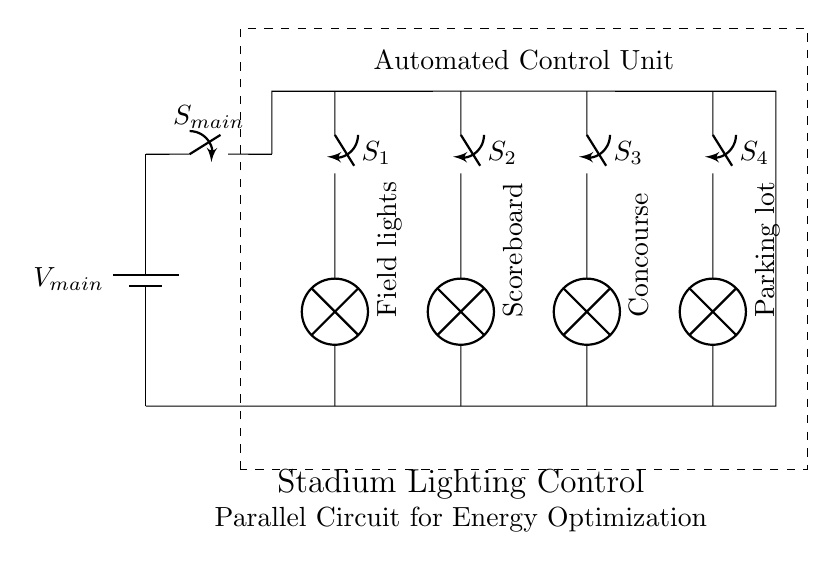What is the main power source in this circuit? The power source is labeled as V_main, indicated at the top left of the circuit diagram.
Answer: V_main How many branches are there in the circuit? There are four branches, each connected to a switch and a lamp, shown as parallel connections.
Answer: Four What does the control unit do? The control unit manages the operation of the entire lighting system by controlling the switches for each branch.
Answer: Automated control What is the purpose of switch S_3? Switch S_3 controls the power to the concourse lights, allowing them to be turned on or off independently from the other lights.
Answer: Concourse lights If all switches are closed, how does current flow? Current flows through each branch independently, allowing multiple lights to operate simultaneously without affecting each other.
Answer: Parallel What happens if switch S_4 is opened? If switch S_4 is opened, the parking lot lights will turn off, but the other branches will remain illuminated.
Answer: Parking lot lights off Which lighting component is directly connected to switch S_1? Switch S_1 is directly connected to the field lights, controlling their operation.
Answer: Field lights 